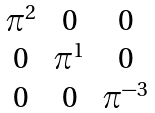Convert formula to latex. <formula><loc_0><loc_0><loc_500><loc_500>\begin{matrix} \pi ^ { 2 } & 0 & 0 \\ 0 & \pi ^ { 1 } & 0 \\ 0 & 0 & \pi ^ { - 3 } \end{matrix}</formula> 